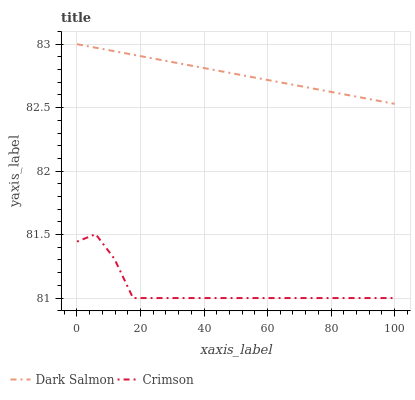Does Crimson have the minimum area under the curve?
Answer yes or no. Yes. Does Dark Salmon have the maximum area under the curve?
Answer yes or no. Yes. Does Dark Salmon have the minimum area under the curve?
Answer yes or no. No. Is Dark Salmon the smoothest?
Answer yes or no. Yes. Is Crimson the roughest?
Answer yes or no. Yes. Is Dark Salmon the roughest?
Answer yes or no. No. Does Crimson have the lowest value?
Answer yes or no. Yes. Does Dark Salmon have the lowest value?
Answer yes or no. No. Does Dark Salmon have the highest value?
Answer yes or no. Yes. Is Crimson less than Dark Salmon?
Answer yes or no. Yes. Is Dark Salmon greater than Crimson?
Answer yes or no. Yes. Does Crimson intersect Dark Salmon?
Answer yes or no. No. 